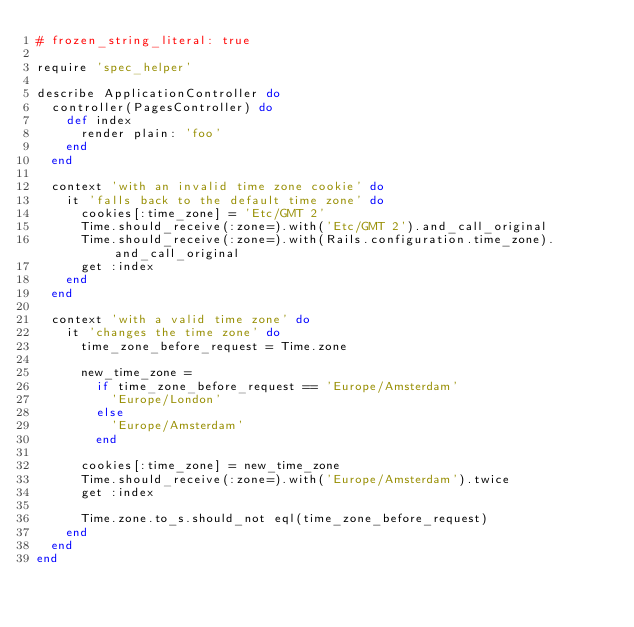<code> <loc_0><loc_0><loc_500><loc_500><_Ruby_># frozen_string_literal: true

require 'spec_helper'

describe ApplicationController do
  controller(PagesController) do
    def index
      render plain: 'foo'
    end
  end

  context 'with an invalid time zone cookie' do
    it 'falls back to the default time zone' do
      cookies[:time_zone] = 'Etc/GMT 2'
      Time.should_receive(:zone=).with('Etc/GMT 2').and_call_original
      Time.should_receive(:zone=).with(Rails.configuration.time_zone).and_call_original
      get :index
    end
  end

  context 'with a valid time zone' do
    it 'changes the time zone' do
      time_zone_before_request = Time.zone

      new_time_zone =
        if time_zone_before_request == 'Europe/Amsterdam'
          'Europe/London'
        else
          'Europe/Amsterdam'
        end

      cookies[:time_zone] = new_time_zone
      Time.should_receive(:zone=).with('Europe/Amsterdam').twice
      get :index

      Time.zone.to_s.should_not eql(time_zone_before_request)
    end
  end
end
</code> 